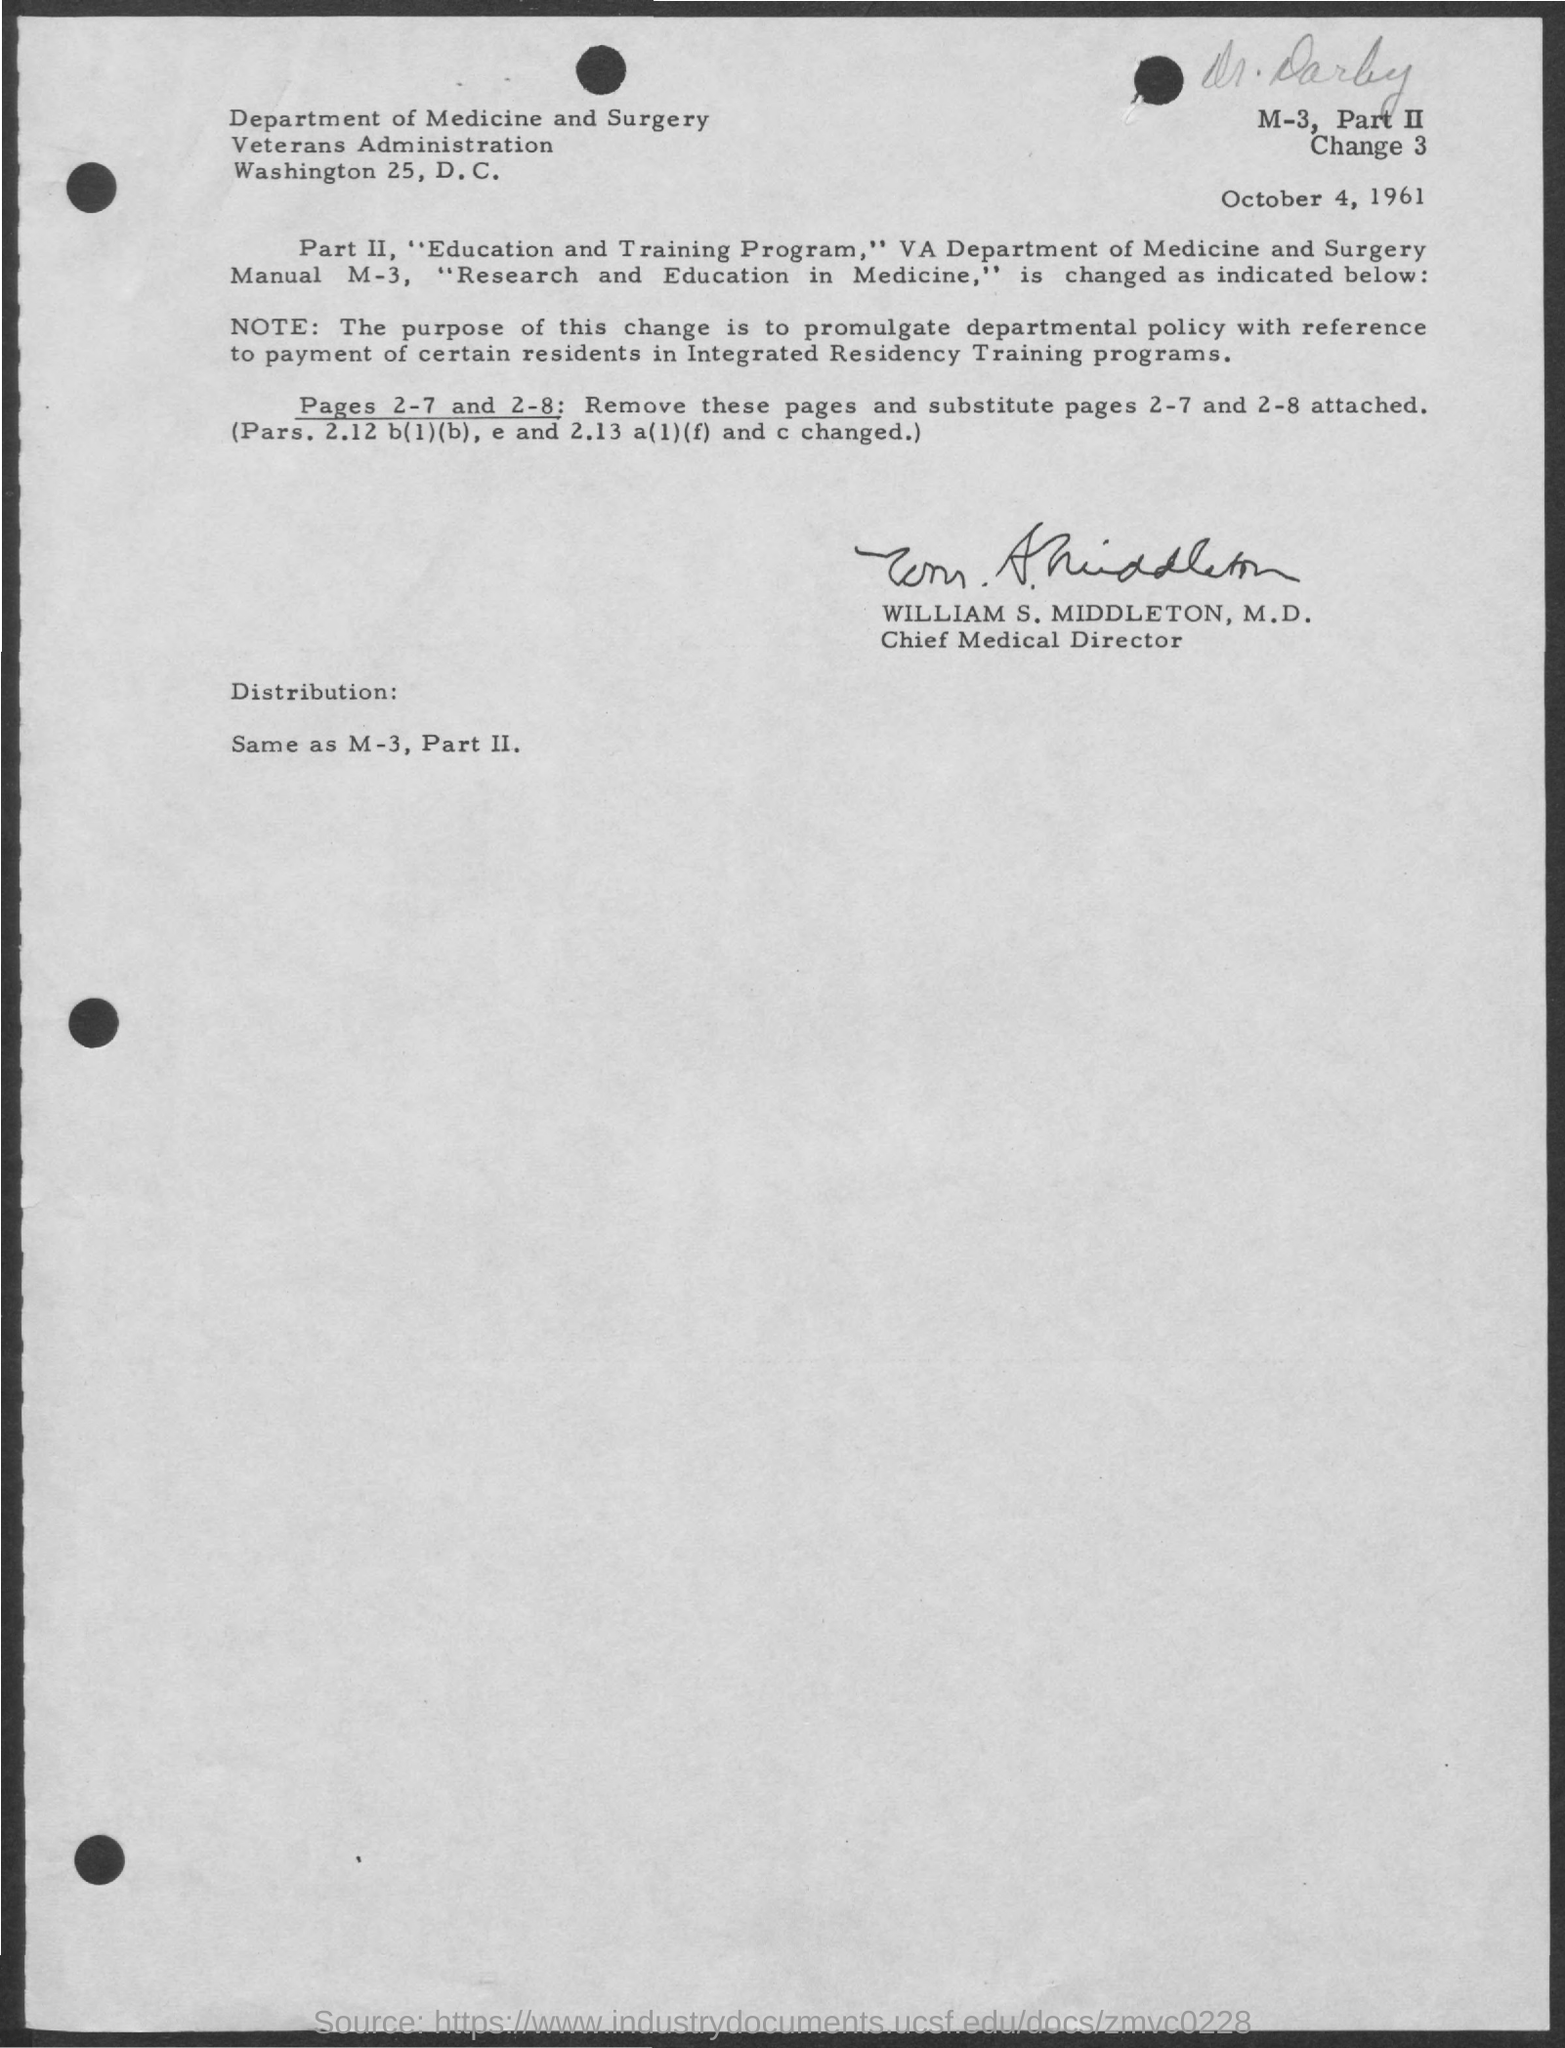Point out several critical features in this image. The Chief Medical Director is William S. Middleton, M.D. The date mentioned in the document is October 4, 1961. 